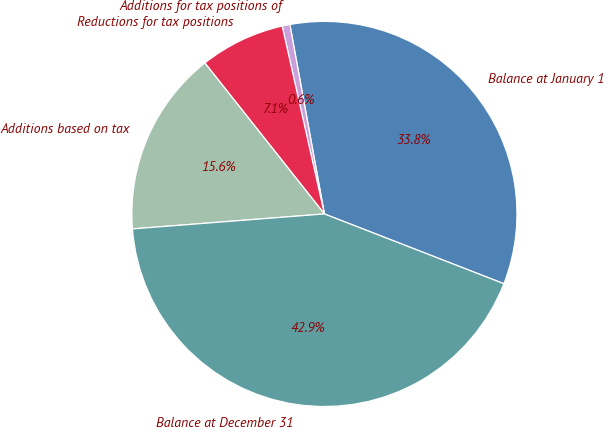<chart> <loc_0><loc_0><loc_500><loc_500><pie_chart><fcel>Balance at January 1<fcel>Additions for tax positions of<fcel>Reductions for tax positions<fcel>Additions based on tax<fcel>Balance at December 31<nl><fcel>33.77%<fcel>0.65%<fcel>7.14%<fcel>15.58%<fcel>42.86%<nl></chart> 